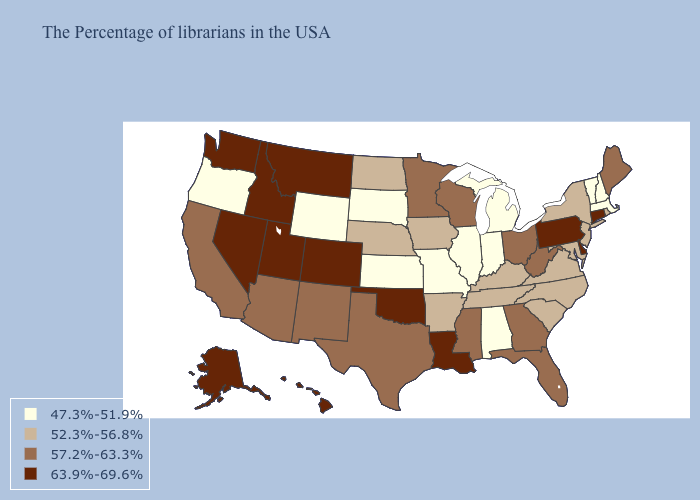Does Wyoming have a higher value than North Dakota?
Quick response, please. No. Which states have the lowest value in the Northeast?
Short answer required. Massachusetts, New Hampshire, Vermont. What is the lowest value in states that border New Hampshire?
Keep it brief. 47.3%-51.9%. Name the states that have a value in the range 63.9%-69.6%?
Quick response, please. Connecticut, Delaware, Pennsylvania, Louisiana, Oklahoma, Colorado, Utah, Montana, Idaho, Nevada, Washington, Alaska, Hawaii. How many symbols are there in the legend?
Answer briefly. 4. Does Maine have a lower value than Nevada?
Short answer required. Yes. What is the value of Washington?
Concise answer only. 63.9%-69.6%. Among the states that border Wisconsin , does Iowa have the lowest value?
Give a very brief answer. No. What is the highest value in the MidWest ?
Quick response, please. 57.2%-63.3%. Does Minnesota have the highest value in the MidWest?
Keep it brief. Yes. What is the highest value in states that border Texas?
Write a very short answer. 63.9%-69.6%. Among the states that border Arizona , does California have the highest value?
Write a very short answer. No. What is the highest value in the MidWest ?
Be succinct. 57.2%-63.3%. What is the value of Pennsylvania?
Quick response, please. 63.9%-69.6%. 